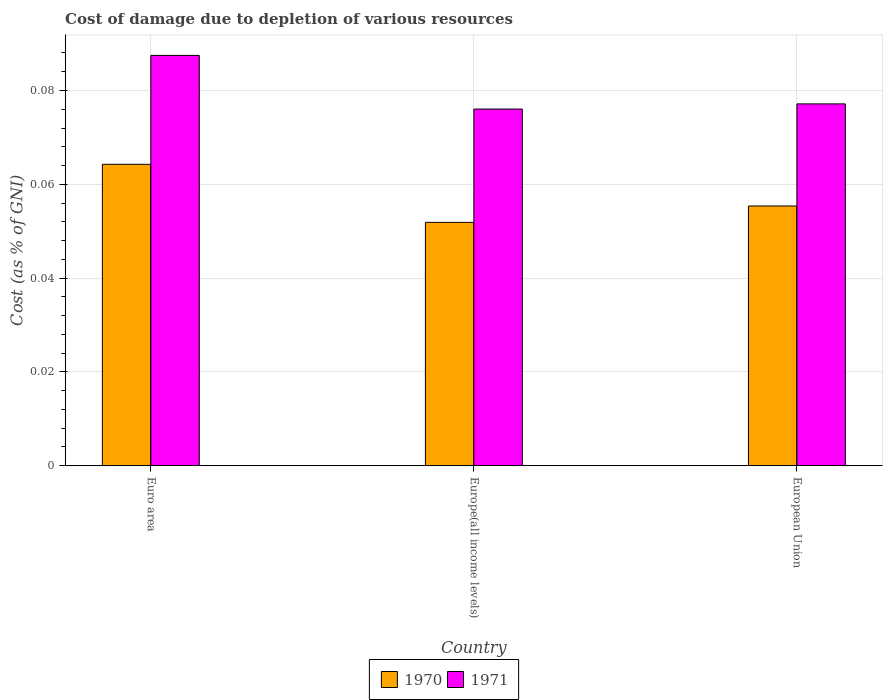How many different coloured bars are there?
Your answer should be very brief. 2. How many groups of bars are there?
Ensure brevity in your answer.  3. Are the number of bars on each tick of the X-axis equal?
Offer a terse response. Yes. How many bars are there on the 3rd tick from the left?
Your answer should be very brief. 2. What is the cost of damage caused due to the depletion of various resources in 1971 in European Union?
Ensure brevity in your answer.  0.08. Across all countries, what is the maximum cost of damage caused due to the depletion of various resources in 1971?
Your answer should be very brief. 0.09. Across all countries, what is the minimum cost of damage caused due to the depletion of various resources in 1970?
Offer a terse response. 0.05. In which country was the cost of damage caused due to the depletion of various resources in 1970 maximum?
Offer a very short reply. Euro area. In which country was the cost of damage caused due to the depletion of various resources in 1971 minimum?
Provide a short and direct response. Europe(all income levels). What is the total cost of damage caused due to the depletion of various resources in 1971 in the graph?
Provide a succinct answer. 0.24. What is the difference between the cost of damage caused due to the depletion of various resources in 1971 in Europe(all income levels) and that in European Union?
Offer a very short reply. -0. What is the difference between the cost of damage caused due to the depletion of various resources in 1970 in Europe(all income levels) and the cost of damage caused due to the depletion of various resources in 1971 in European Union?
Your response must be concise. -0.03. What is the average cost of damage caused due to the depletion of various resources in 1970 per country?
Provide a short and direct response. 0.06. What is the difference between the cost of damage caused due to the depletion of various resources of/in 1970 and cost of damage caused due to the depletion of various resources of/in 1971 in Europe(all income levels)?
Offer a terse response. -0.02. What is the ratio of the cost of damage caused due to the depletion of various resources in 1970 in Euro area to that in European Union?
Make the answer very short. 1.16. Is the difference between the cost of damage caused due to the depletion of various resources in 1970 in Europe(all income levels) and European Union greater than the difference between the cost of damage caused due to the depletion of various resources in 1971 in Europe(all income levels) and European Union?
Keep it short and to the point. No. What is the difference between the highest and the second highest cost of damage caused due to the depletion of various resources in 1971?
Offer a terse response. 0.01. What is the difference between the highest and the lowest cost of damage caused due to the depletion of various resources in 1971?
Give a very brief answer. 0.01. In how many countries, is the cost of damage caused due to the depletion of various resources in 1971 greater than the average cost of damage caused due to the depletion of various resources in 1971 taken over all countries?
Provide a short and direct response. 1. Is the sum of the cost of damage caused due to the depletion of various resources in 1970 in Europe(all income levels) and European Union greater than the maximum cost of damage caused due to the depletion of various resources in 1971 across all countries?
Your answer should be compact. Yes. How many countries are there in the graph?
Provide a short and direct response. 3. What is the difference between two consecutive major ticks on the Y-axis?
Offer a terse response. 0.02. Does the graph contain any zero values?
Give a very brief answer. No. Where does the legend appear in the graph?
Your answer should be compact. Bottom center. How many legend labels are there?
Provide a succinct answer. 2. How are the legend labels stacked?
Offer a very short reply. Horizontal. What is the title of the graph?
Give a very brief answer. Cost of damage due to depletion of various resources. What is the label or title of the Y-axis?
Keep it short and to the point. Cost (as % of GNI). What is the Cost (as % of GNI) in 1970 in Euro area?
Your answer should be compact. 0.06. What is the Cost (as % of GNI) in 1971 in Euro area?
Provide a succinct answer. 0.09. What is the Cost (as % of GNI) in 1970 in Europe(all income levels)?
Offer a terse response. 0.05. What is the Cost (as % of GNI) of 1971 in Europe(all income levels)?
Provide a short and direct response. 0.08. What is the Cost (as % of GNI) of 1970 in European Union?
Offer a very short reply. 0.06. What is the Cost (as % of GNI) of 1971 in European Union?
Offer a very short reply. 0.08. Across all countries, what is the maximum Cost (as % of GNI) of 1970?
Ensure brevity in your answer.  0.06. Across all countries, what is the maximum Cost (as % of GNI) of 1971?
Your answer should be compact. 0.09. Across all countries, what is the minimum Cost (as % of GNI) in 1970?
Offer a very short reply. 0.05. Across all countries, what is the minimum Cost (as % of GNI) of 1971?
Keep it short and to the point. 0.08. What is the total Cost (as % of GNI) in 1970 in the graph?
Your response must be concise. 0.17. What is the total Cost (as % of GNI) in 1971 in the graph?
Ensure brevity in your answer.  0.24. What is the difference between the Cost (as % of GNI) of 1970 in Euro area and that in Europe(all income levels)?
Make the answer very short. 0.01. What is the difference between the Cost (as % of GNI) of 1971 in Euro area and that in Europe(all income levels)?
Your response must be concise. 0.01. What is the difference between the Cost (as % of GNI) in 1970 in Euro area and that in European Union?
Your response must be concise. 0.01. What is the difference between the Cost (as % of GNI) of 1971 in Euro area and that in European Union?
Provide a succinct answer. 0.01. What is the difference between the Cost (as % of GNI) of 1970 in Europe(all income levels) and that in European Union?
Offer a terse response. -0. What is the difference between the Cost (as % of GNI) of 1971 in Europe(all income levels) and that in European Union?
Offer a terse response. -0. What is the difference between the Cost (as % of GNI) of 1970 in Euro area and the Cost (as % of GNI) of 1971 in Europe(all income levels)?
Give a very brief answer. -0.01. What is the difference between the Cost (as % of GNI) of 1970 in Euro area and the Cost (as % of GNI) of 1971 in European Union?
Your response must be concise. -0.01. What is the difference between the Cost (as % of GNI) in 1970 in Europe(all income levels) and the Cost (as % of GNI) in 1971 in European Union?
Offer a very short reply. -0.03. What is the average Cost (as % of GNI) in 1970 per country?
Offer a very short reply. 0.06. What is the average Cost (as % of GNI) of 1971 per country?
Provide a short and direct response. 0.08. What is the difference between the Cost (as % of GNI) of 1970 and Cost (as % of GNI) of 1971 in Euro area?
Provide a short and direct response. -0.02. What is the difference between the Cost (as % of GNI) in 1970 and Cost (as % of GNI) in 1971 in Europe(all income levels)?
Give a very brief answer. -0.02. What is the difference between the Cost (as % of GNI) in 1970 and Cost (as % of GNI) in 1971 in European Union?
Give a very brief answer. -0.02. What is the ratio of the Cost (as % of GNI) in 1970 in Euro area to that in Europe(all income levels)?
Offer a terse response. 1.24. What is the ratio of the Cost (as % of GNI) of 1971 in Euro area to that in Europe(all income levels)?
Offer a very short reply. 1.15. What is the ratio of the Cost (as % of GNI) in 1970 in Euro area to that in European Union?
Your answer should be compact. 1.16. What is the ratio of the Cost (as % of GNI) of 1971 in Euro area to that in European Union?
Provide a succinct answer. 1.13. What is the ratio of the Cost (as % of GNI) of 1970 in Europe(all income levels) to that in European Union?
Ensure brevity in your answer.  0.94. What is the ratio of the Cost (as % of GNI) in 1971 in Europe(all income levels) to that in European Union?
Ensure brevity in your answer.  0.99. What is the difference between the highest and the second highest Cost (as % of GNI) of 1970?
Make the answer very short. 0.01. What is the difference between the highest and the second highest Cost (as % of GNI) in 1971?
Ensure brevity in your answer.  0.01. What is the difference between the highest and the lowest Cost (as % of GNI) in 1970?
Your answer should be compact. 0.01. What is the difference between the highest and the lowest Cost (as % of GNI) of 1971?
Offer a very short reply. 0.01. 